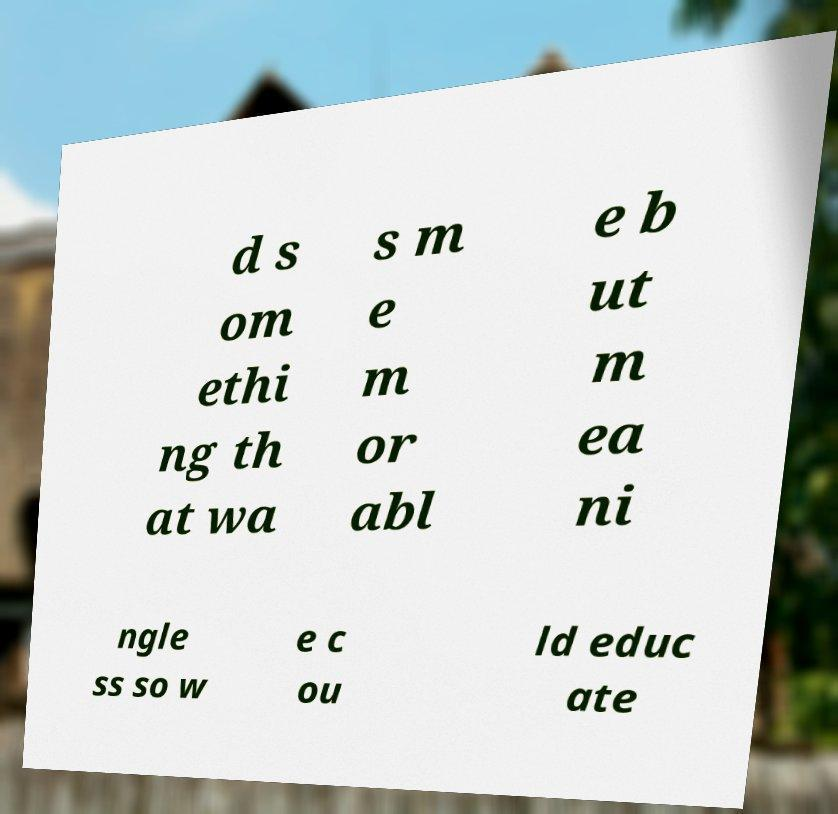I need the written content from this picture converted into text. Can you do that? d s om ethi ng th at wa s m e m or abl e b ut m ea ni ngle ss so w e c ou ld educ ate 